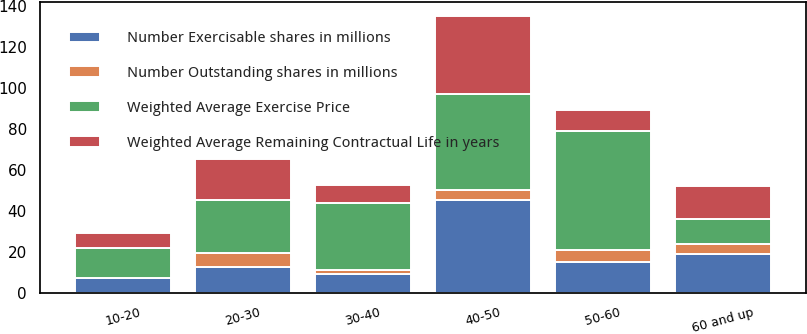Convert chart to OTSL. <chart><loc_0><loc_0><loc_500><loc_500><stacked_bar_chart><ecel><fcel>10-20<fcel>20-30<fcel>30-40<fcel>40-50<fcel>50-60<fcel>60 and up<nl><fcel>Number Exercisable shares in millions<fcel>7<fcel>12.375<fcel>9<fcel>45<fcel>15<fcel>19<nl><fcel>Number Outstanding shares in millions<fcel>0.16<fcel>7.07<fcel>2.21<fcel>4.86<fcel>6.01<fcel>4.48<nl><fcel>Weighted Average Exercise Price<fcel>14.75<fcel>25.78<fcel>32.39<fcel>47.01<fcel>58.06<fcel>12.375<nl><fcel>Weighted Average Remaining Contractual Life in years<fcel>7<fcel>20<fcel>9<fcel>38<fcel>10<fcel>16<nl></chart> 